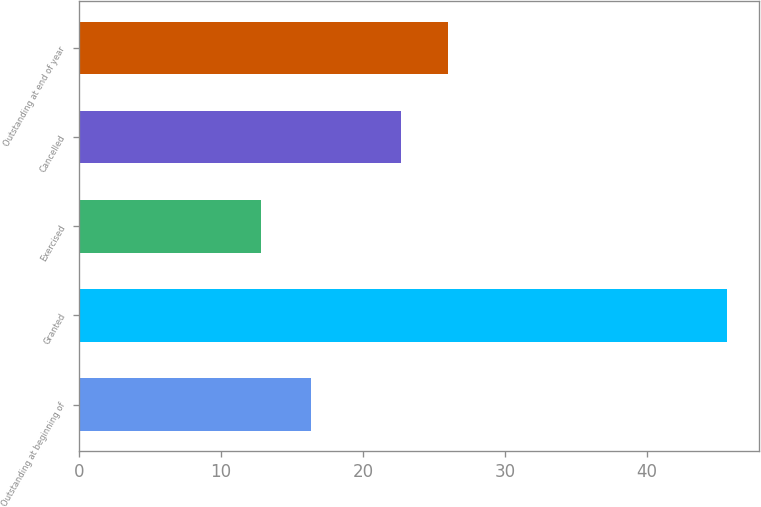Convert chart to OTSL. <chart><loc_0><loc_0><loc_500><loc_500><bar_chart><fcel>Outstanding at beginning of<fcel>Granted<fcel>Exercised<fcel>Cancelled<fcel>Outstanding at end of year<nl><fcel>16.38<fcel>45.63<fcel>12.81<fcel>22.68<fcel>25.96<nl></chart> 